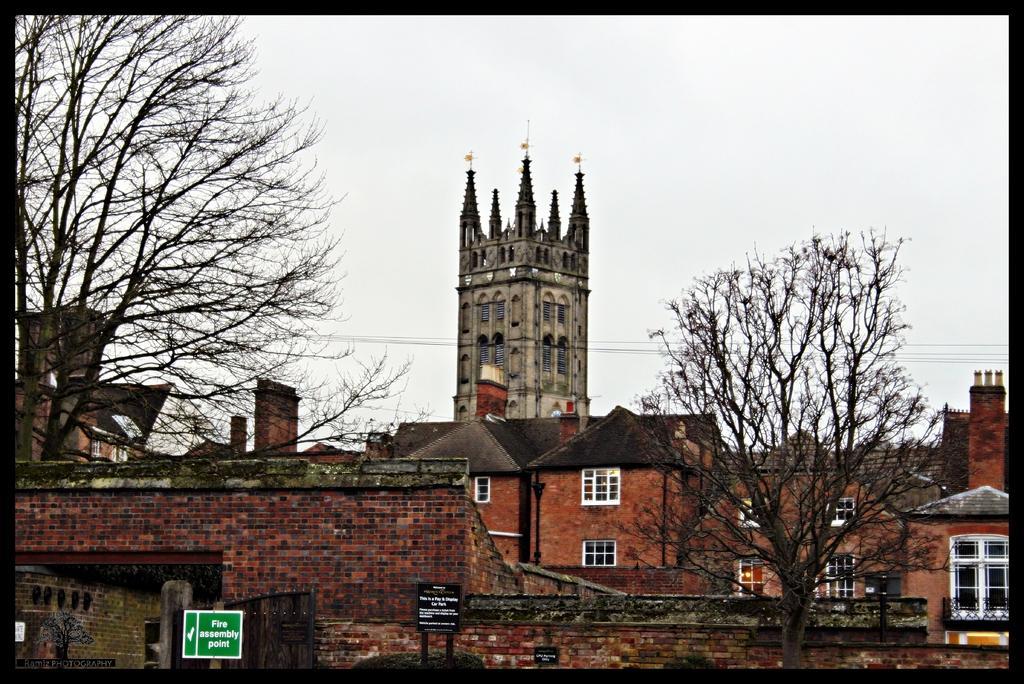Please provide a concise description of this image. In this picture I can see number of buildings and few trees in front and I can see few wires. In the background I can see the sky. On the bottom side of this picture I can see 2 boards and I see something is written on them. 